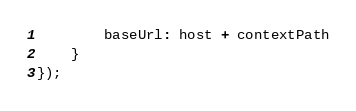Convert code to text. <code><loc_0><loc_0><loc_500><loc_500><_JavaScript_>        baseUrl: host + contextPath
    }
});</code> 